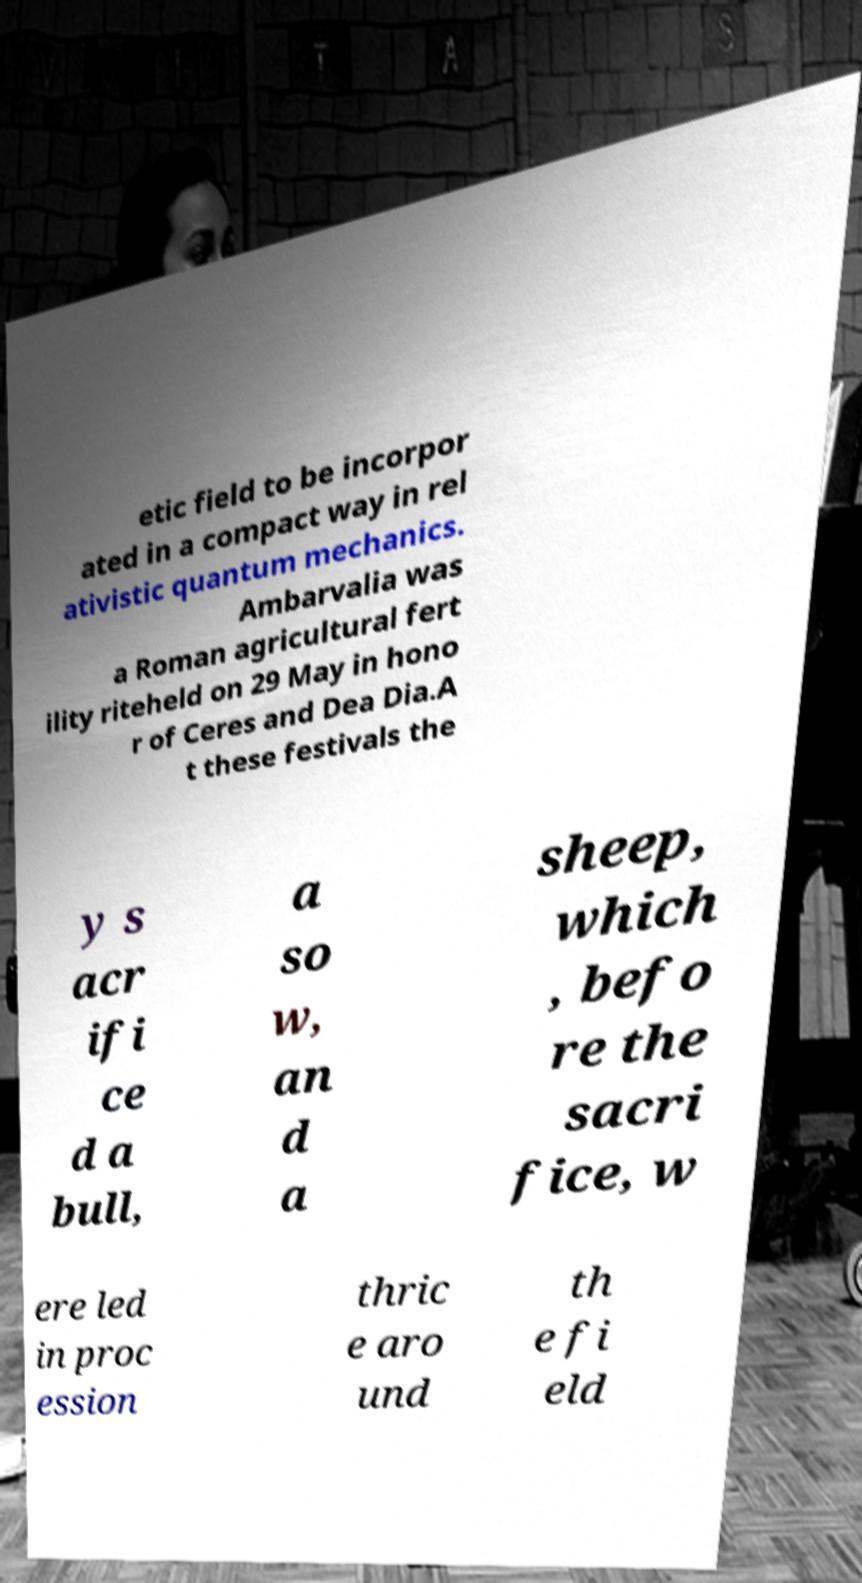There's text embedded in this image that I need extracted. Can you transcribe it verbatim? etic field to be incorpor ated in a compact way in rel ativistic quantum mechanics. Ambarvalia was a Roman agricultural fert ility riteheld on 29 May in hono r of Ceres and Dea Dia.A t these festivals the y s acr ifi ce d a bull, a so w, an d a sheep, which , befo re the sacri fice, w ere led in proc ession thric e aro und th e fi eld 